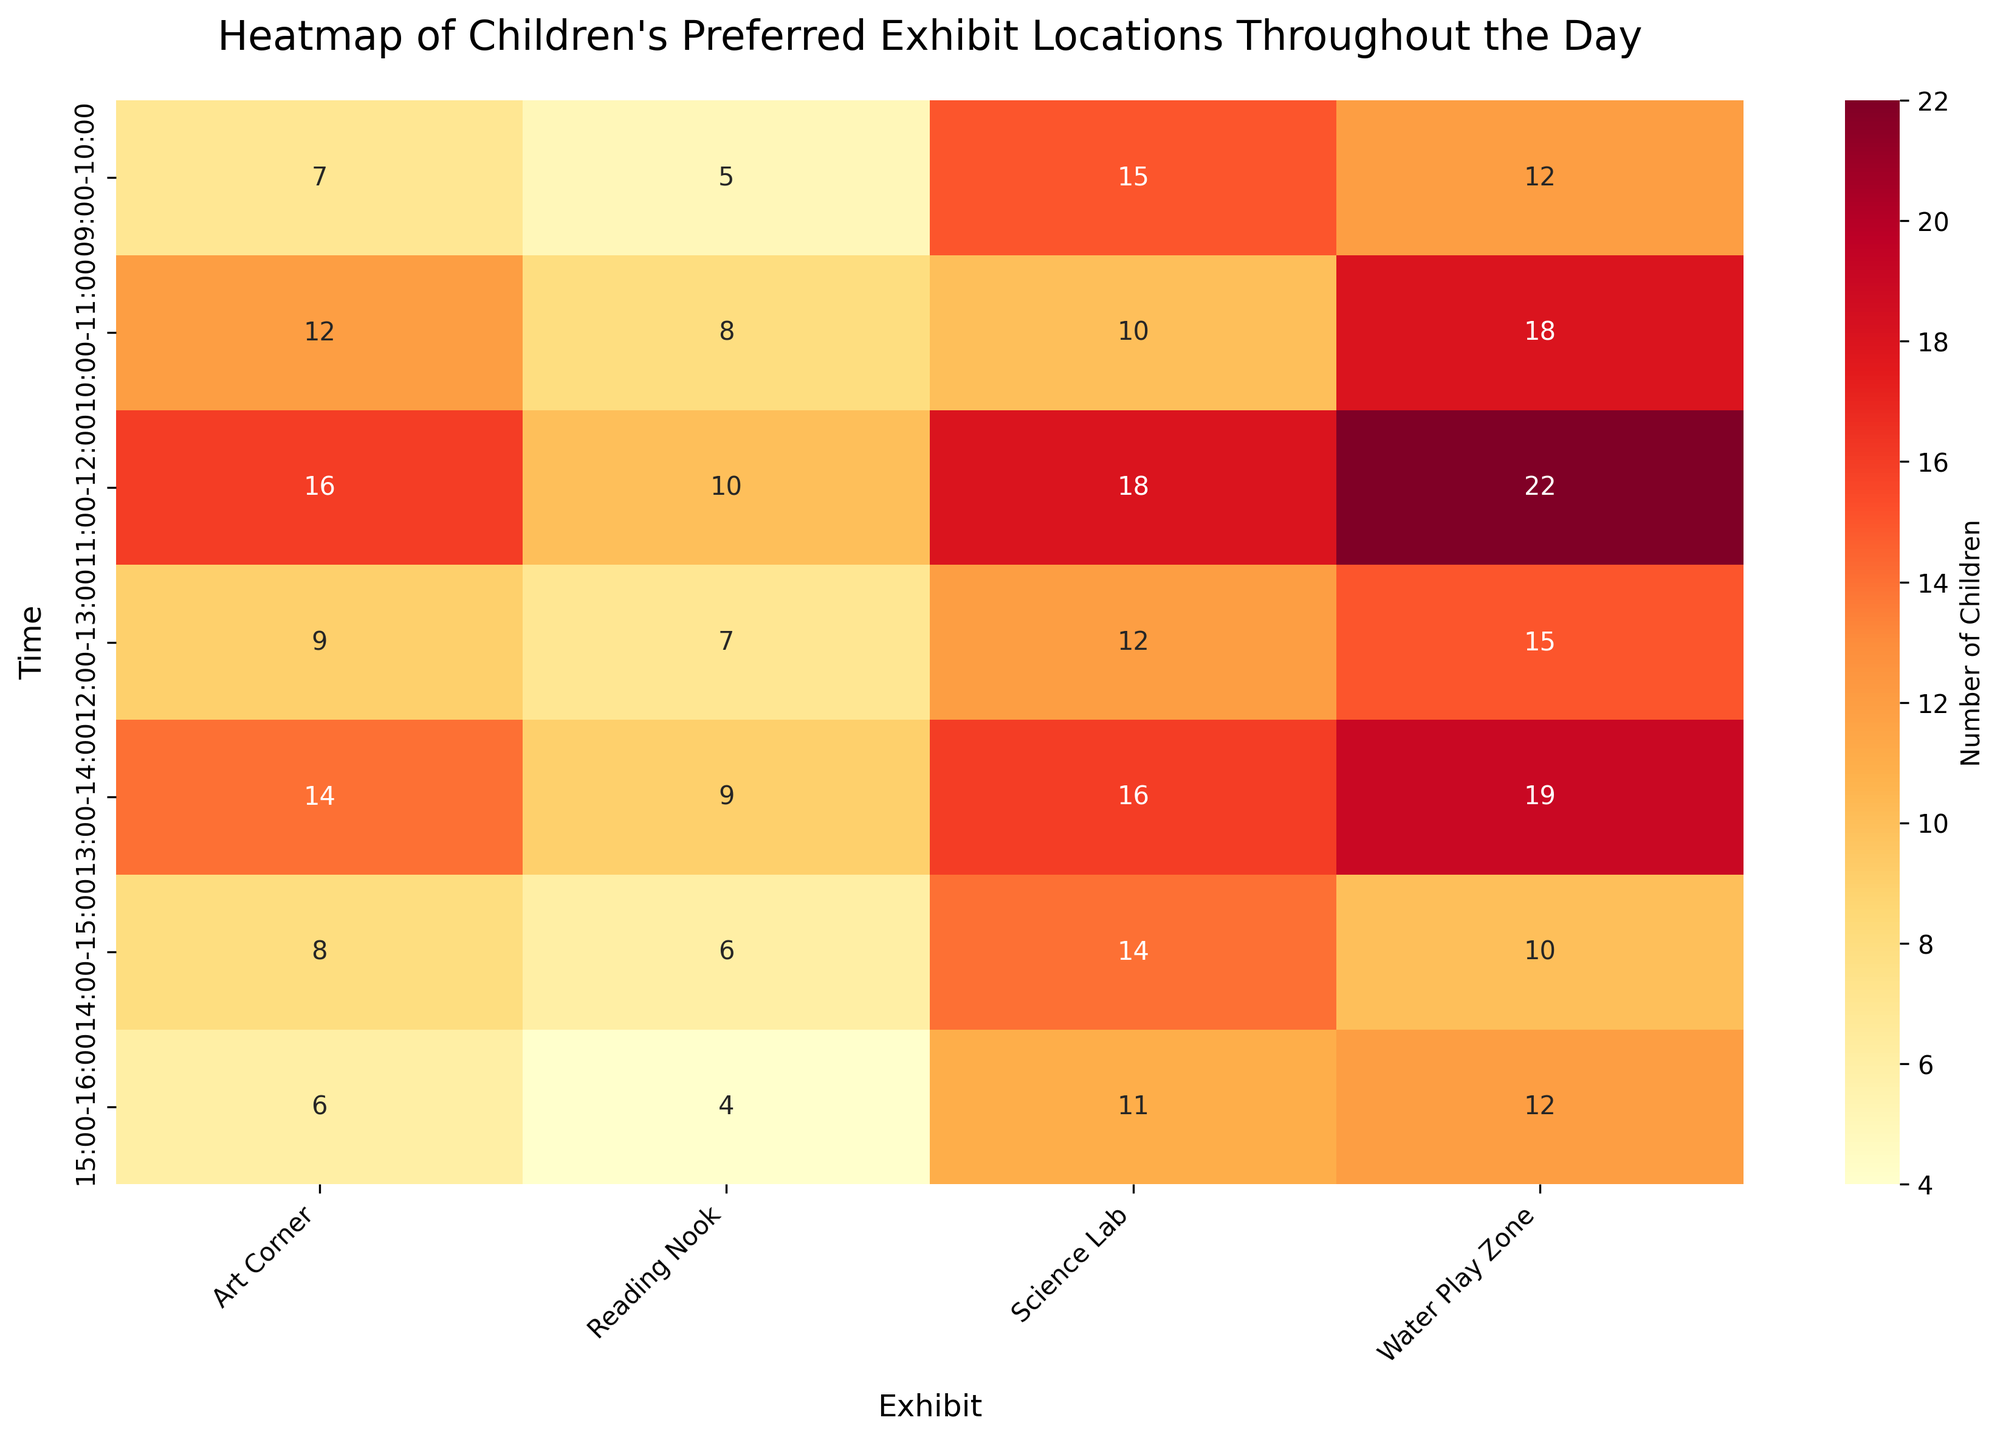What is the title of the heatmap? The title can be found at the top of the figure, which describes what the heatmap represents.
Answer: Heatmap of Children's Preferred Exhibit Locations Throughout the Day How many time intervals are represented on the heatmap? Look at the y-axis of the heatmap, which lists the different time intervals. Count the number of unique intervals.
Answer: 7 Which exhibit had the highest number of children from 11:00 to 12:00? Find the row corresponding to '11:00-12:00' and identify the cell with the highest value in that row.
Answer: Water Play Zone What is the total number of children at the Water Play Zone throughout the day? Sum the values in the column for 'Water Play Zone'.
Answer: 108 During which time interval did the Reading Nook have the least number of children? Find the column for 'Reading Nook' and locate the cell with the lowest value, then read off the corresponding time interval from the y-axis.
Answer: 15:00-16:00 How many more children visited the Science Lab from 11:00 to 12:00 compared to 15:00 to 16:00? Find the number of children for both intervals in the Science Lab column and subtract the latter from the former.
Answer: 7 Which exhibit has the most balanced (minimal variation) number of children throughout the day? Look at the columns and visually identify which one has values that are most similar to each other.
Answer: Reading Nook What is the average number of children at the Art Corner throughout the day? Sum the values in the 'Art Corner' column and divide by the number of time intervals.
Answer: 10 Compare the number of children at the Water Play Zone and Science Lab from 13:00 to 14:00. Which one had more children and by how much? Find the values for both exhibits at the specified time and subtract the smaller value from the larger one.
Answer: Water Play Zone by 3 Which exhibit saw the largest increase in children's attendance from one time interval to the next, and during which interval did this occur? Calculate the differences in attendance for each exhibit between consecutive time intervals and find the largest increase. Note both the exhibit and time interval.
Answer: Water Play Zone from 09:00-10:00 to 10:00-11:00, 6 